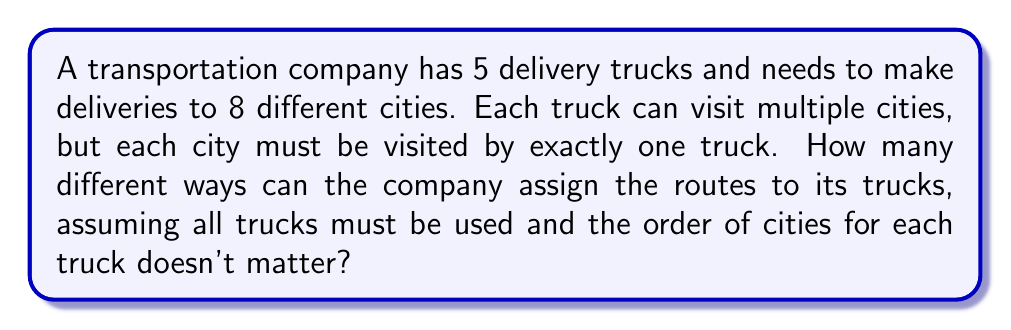Help me with this question. This problem can be solved using the concept of partitioning a set and Stirling numbers of the second kind. Let's break it down step by step:

1) We need to partition 8 cities into 5 non-empty subsets (one for each truck).

2) This is equivalent to finding the number of ways to partition a set of 8 elements into 5 non-empty subsets, which is denoted by the Stirling number of the second kind: $\stirling{8}{5}$

3) To calculate $\stirling{8}{5}$, we can use the following formula:

   $$\stirling{n}{k} = \frac{1}{k!}\sum_{i=0}^k (-1)^i \binom{k}{i}(k-i)^n$$

4) Substituting $n=8$ and $k=5$:

   $$\stirling{8}{5} = \frac{1}{5!}\sum_{i=0}^5 (-1)^i \binom{5}{i}(5-i)^8$$

5) Expanding this sum:

   $$\begin{align*}
   \stirling{8}{5} &= \frac{1}{120}[\binom{5}{0}5^8 - \binom{5}{1}4^8 + \binom{5}{2}3^8 - \binom{5}{3}2^8 + \binom{5}{4}1^8 - \binom{5}{5}0^8] \\
   &= \frac{1}{120}[390625 - 5242880 + 4251528 - 320000 + 3125 - 0] \\
   &= \frac{-917602}{120} \\
   &= 7646.68333...
   \end{align*}$$

6) Since we're counting whole arrangements, we round down to 7646.

Therefore, there are 7646 different ways to assign the routes to the trucks.
Answer: 7646 